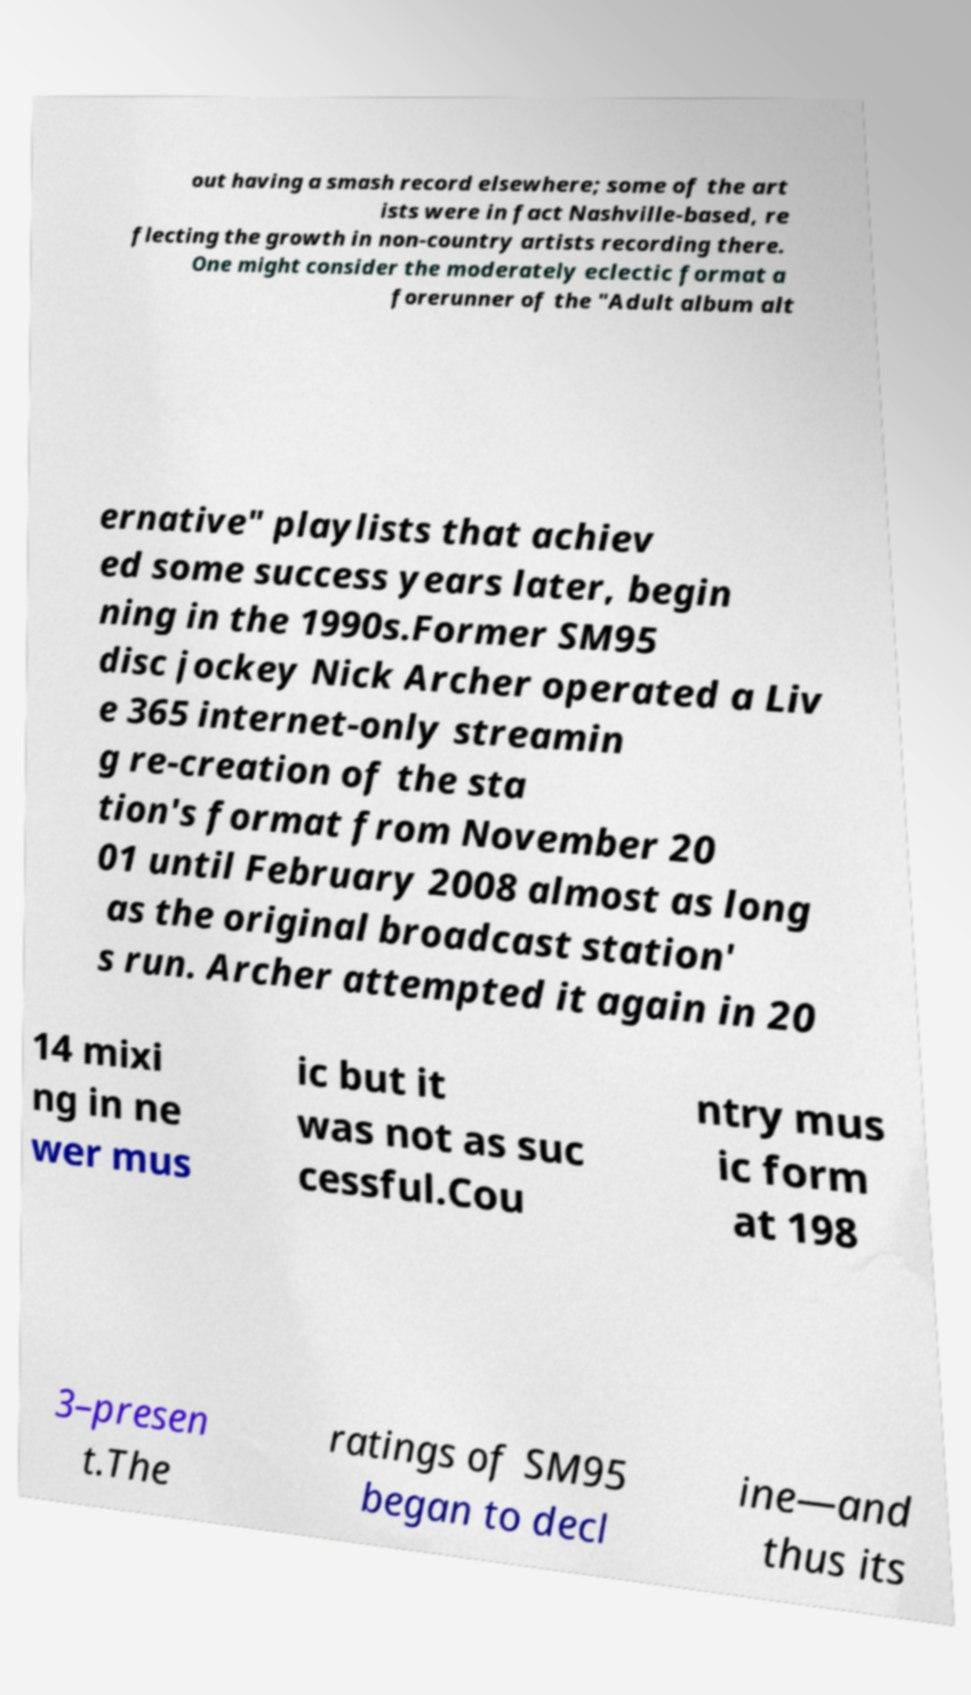I need the written content from this picture converted into text. Can you do that? out having a smash record elsewhere; some of the art ists were in fact Nashville-based, re flecting the growth in non-country artists recording there. One might consider the moderately eclectic format a forerunner of the "Adult album alt ernative" playlists that achiev ed some success years later, begin ning in the 1990s.Former SM95 disc jockey Nick Archer operated a Liv e 365 internet-only streamin g re-creation of the sta tion's format from November 20 01 until February 2008 almost as long as the original broadcast station' s run. Archer attempted it again in 20 14 mixi ng in ne wer mus ic but it was not as suc cessful.Cou ntry mus ic form at 198 3–presen t.The ratings of SM95 began to decl ine—and thus its 